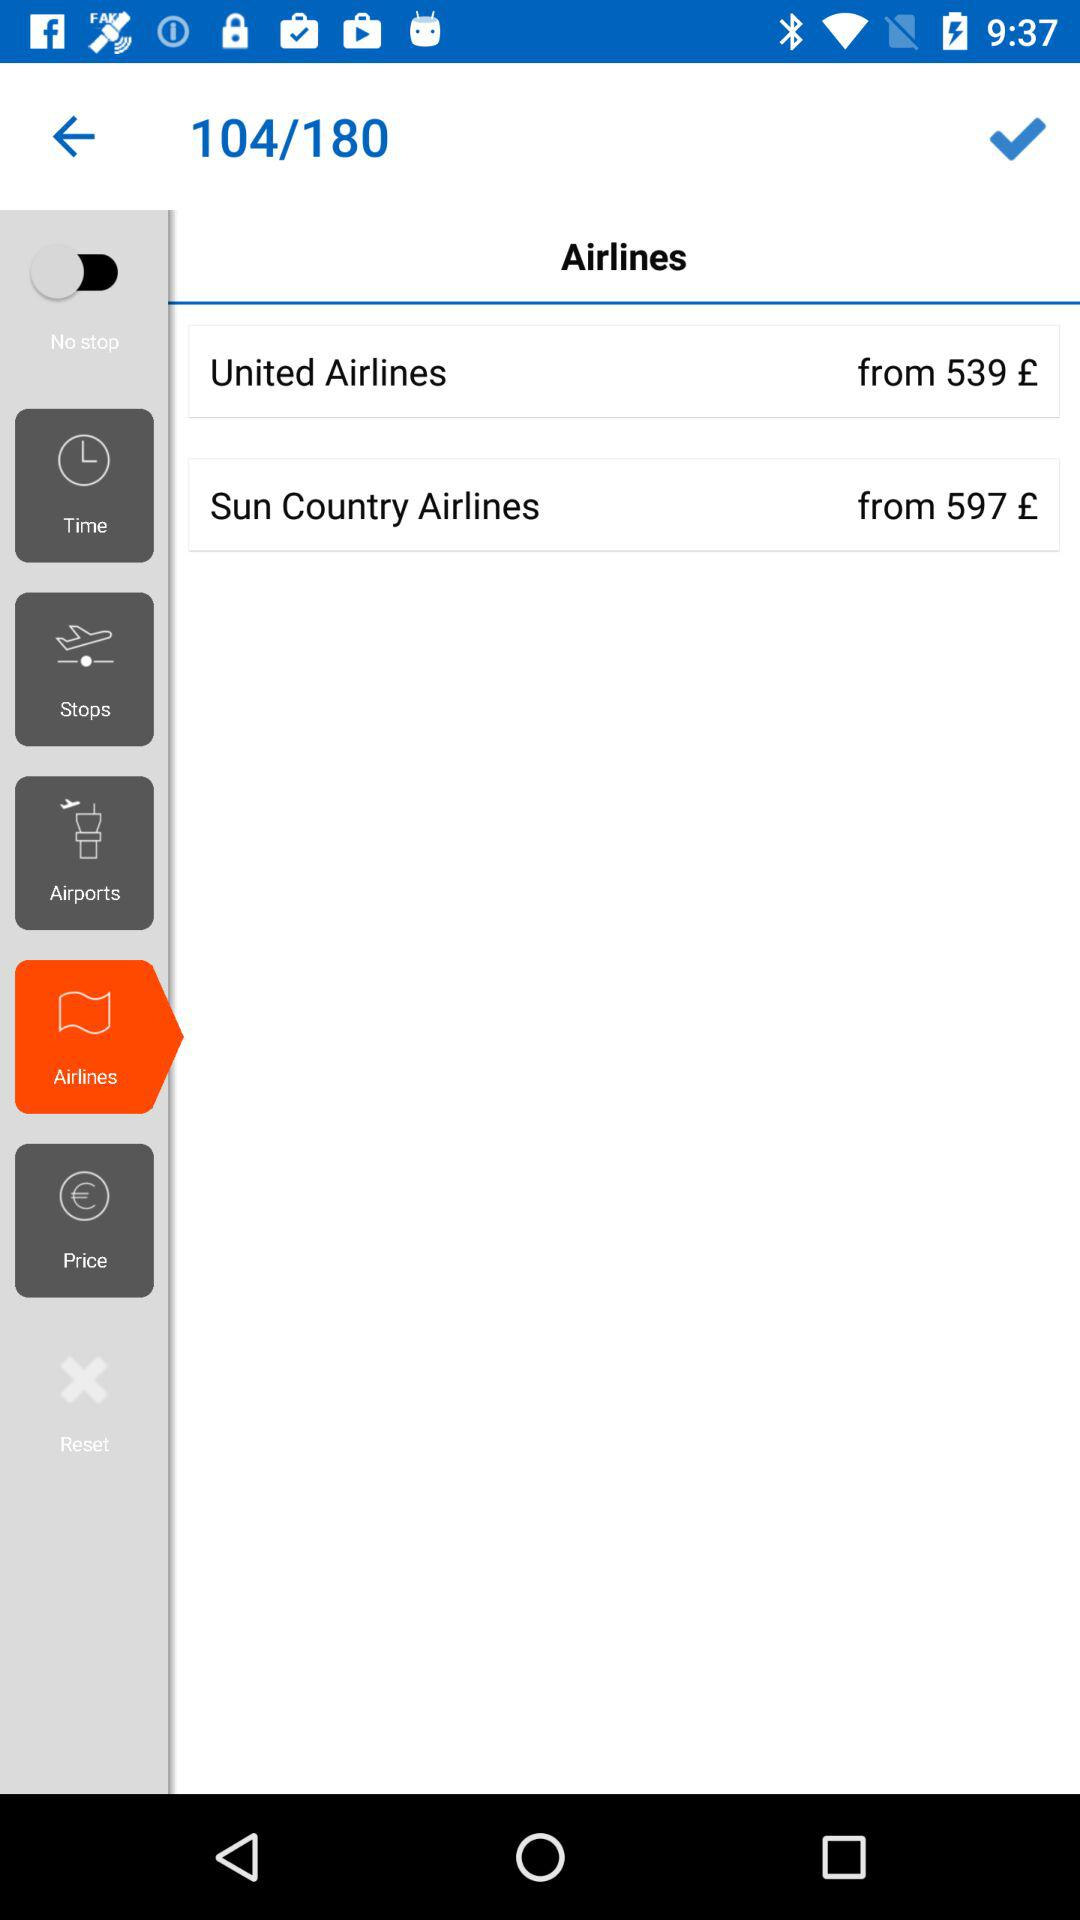What's the status of the "No stop"? The status is "off". 